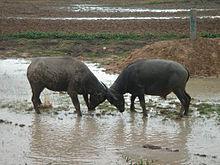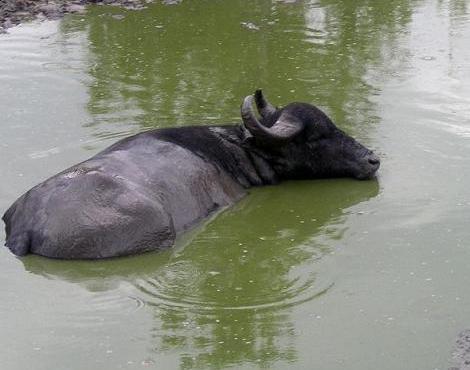The first image is the image on the left, the second image is the image on the right. Assess this claim about the two images: "In at least one image the oxen is partially submerged, past the legs, in water.". Correct or not? Answer yes or no. Yes. 